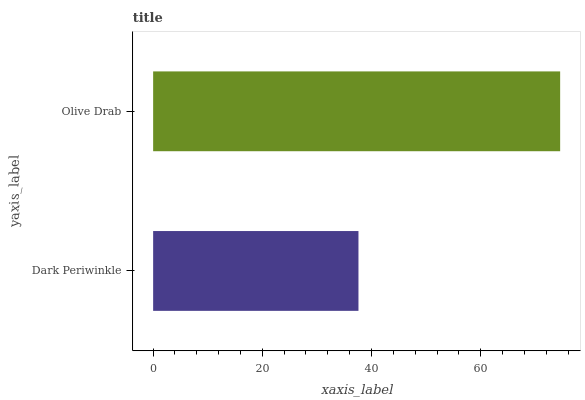Is Dark Periwinkle the minimum?
Answer yes or no. Yes. Is Olive Drab the maximum?
Answer yes or no. Yes. Is Olive Drab the minimum?
Answer yes or no. No. Is Olive Drab greater than Dark Periwinkle?
Answer yes or no. Yes. Is Dark Periwinkle less than Olive Drab?
Answer yes or no. Yes. Is Dark Periwinkle greater than Olive Drab?
Answer yes or no. No. Is Olive Drab less than Dark Periwinkle?
Answer yes or no. No. Is Olive Drab the high median?
Answer yes or no. Yes. Is Dark Periwinkle the low median?
Answer yes or no. Yes. Is Dark Periwinkle the high median?
Answer yes or no. No. Is Olive Drab the low median?
Answer yes or no. No. 